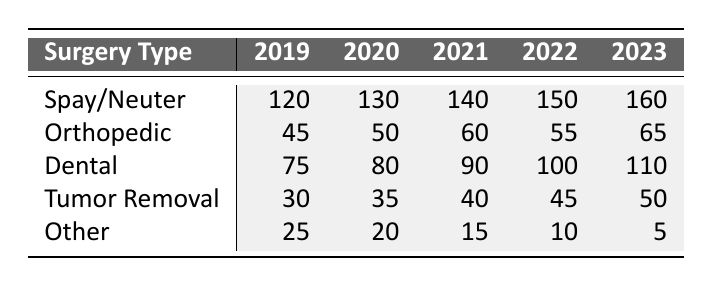What was the total number of spay/neuter surgeries performed in 2021? In the table, the number of spay/neuter surgeries for 2021 is directly listed as 140. Therefore, the total number is simply this value.
Answer: 140 How many dental surgeries were performed in 2020? The table shows that 80 dental surgeries were performed in 2020.
Answer: 80 What type of surgery saw the highest increase from 2019 to 2023? By comparing the numbers, spay/neuter surgeries increased from 120 in 2019 to 160 in 2023, which is an increase of 40. Dental surgeries also rose from 75 to 110, an increase of 35. Thus, spay/neuter had the highest increase.
Answer: Spay/neuter What was the average number of other surgeries performed over the years? The numbers for other surgeries from 2019 to 2023 are 25, 20, 15, 10, and 5. We calculate the average: (25 + 20 + 15 + 10 + 5) / 5 = 15.
Answer: 15 Did the number of tumor removal surgeries increase every year from 2019 to 2023? The figures for tumor removal surgeries are 30, 35, 40, 45, and 50 from 2019 to 2023, which indicates a consistent increase each year.
Answer: Yes What was the total number of orthopedic surgeries performed from 2019 to 2023? The total can be found by summing the orthopedic surgeries for each year: 45 + 50 + 60 + 55 + 65 = 275.
Answer: 275 In which year was the number of other surgeries the lowest? By examining the data, it is evident that in 2023, the number of other surgeries was 5, which is the lowest compared to previous years.
Answer: 2023 How many more dental surgeries were performed in 2022 than in 2019? The number of dental surgeries in 2022 is 100, and in 2019 it is 75. To find the difference, we subtract 75 from 100: 100 - 75 = 25.
Answer: 25 What was the total number of surgeries performed in 2023 for all types combined? We add all surgery types for 2023: 160 (spay/neuter) + 65 (orthopedic) + 110 (dental) + 50 (tumor removal) + 5 (other) = 390.
Answer: 390 Which year had the least number of 'other' surgeries performed, and what was that number? The 'other' surgeries decreased each year, reaching a minimum of 5 in 2023, making it the year with the least.
Answer: 5 